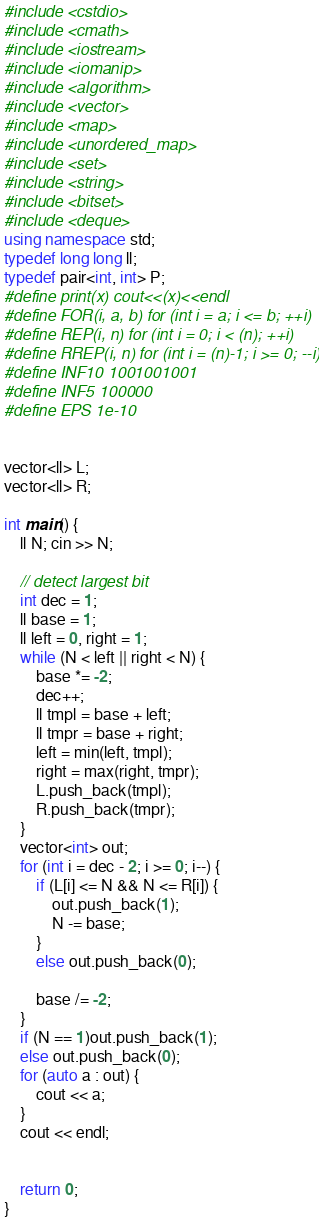Convert code to text. <code><loc_0><loc_0><loc_500><loc_500><_C++_>#include <cstdio>
#include <cmath>
#include <iostream>
#include <iomanip>
#include <algorithm>
#include <vector>
#include <map>
#include <unordered_map>
#include <set>
#include <string>
#include <bitset>
#include <deque>
using namespace std;
typedef long long ll;
typedef pair<int, int> P;
#define print(x) cout<<(x)<<endl
#define FOR(i, a, b) for (int i = a; i <= b; ++i)
#define REP(i, n) for (int i = 0; i < (n); ++i)
#define RREP(i, n) for (int i = (n)-1; i >= 0; --i)
#define INF10 1001001001 
#define INF5 100000
#define EPS 1e-10


vector<ll> L;
vector<ll> R;

int main() {
	ll N; cin >> N;

	// detect largest bit
	int dec = 1;
	ll base = 1;
	ll left = 0, right = 1;
	while (N < left || right < N) {
		base *= -2;
		dec++;
		ll tmpl = base + left;
		ll tmpr = base + right;
		left = min(left, tmpl);
		right = max(right, tmpr);
		L.push_back(tmpl);
		R.push_back(tmpr);
	}
	vector<int> out;
	for (int i = dec - 2; i >= 0; i--) {
		if (L[i] <= N && N <= R[i]) {
			out.push_back(1);
			N -= base;
		}
		else out.push_back(0);

		base /= -2;
	}
	if (N == 1)out.push_back(1);
	else out.push_back(0);
	for (auto a : out) {
		cout << a;
	}
	cout << endl;


	return 0;
}
</code> 